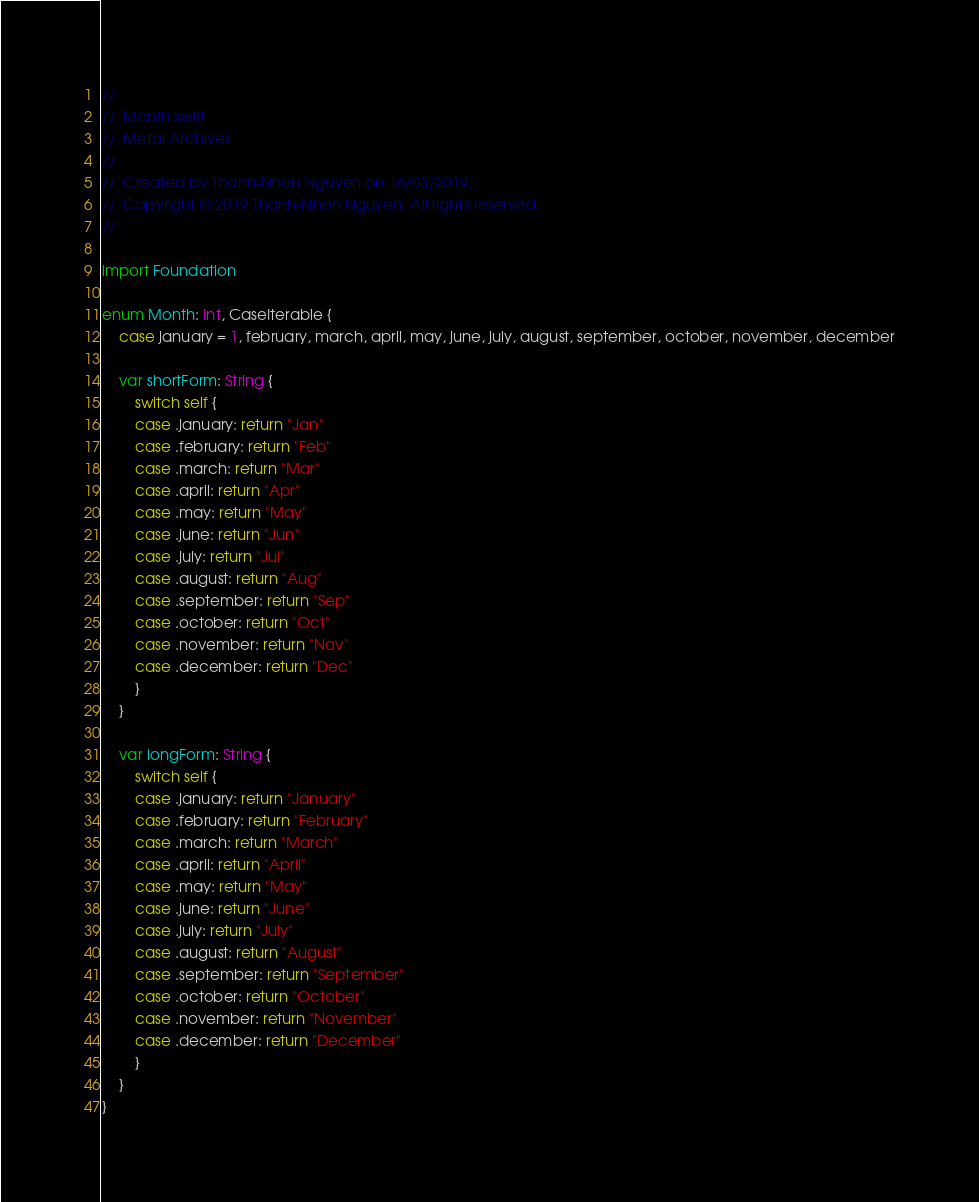<code> <loc_0><loc_0><loc_500><loc_500><_Swift_>//
//  Month.swift
//  Metal Archives
//
//  Created by Thanh-Nhon Nguyen on 16/03/2019.
//  Copyright © 2019 Thanh-Nhon Nguyen. All rights reserved.
//

import Foundation

enum Month: Int, CaseIterable {
    case january = 1, february, march, april, may, june, july, august, september, october, november, december
    
    var shortForm: String {
        switch self {
        case .january: return "Jan"
        case .february: return "Feb"
        case .march: return "Mar"
        case .april: return "Apr"
        case .may: return "May"
        case .june: return "Jun"
        case .july: return "Jul"
        case .august: return "Aug"
        case .september: return "Sep"
        case .october: return "Oct"
        case .november: return "Nov"
        case .december: return "Dec"
        }
    }
    
    var longForm: String {
        switch self {
        case .january: return "January"
        case .february: return "February"
        case .march: return "March"
        case .april: return "April"
        case .may: return "May"
        case .june: return "June"
        case .july: return "July"
        case .august: return "August"
        case .september: return "September"
        case .october: return "October"
        case .november: return "November"
        case .december: return "December"
        }
    }
}
</code> 